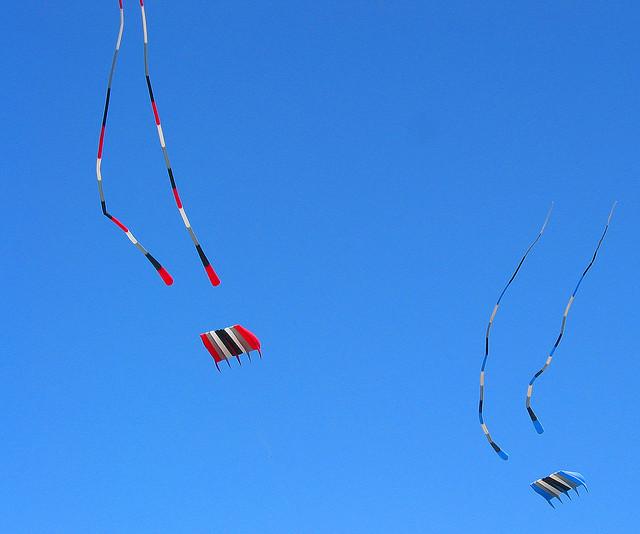What is flying in the air?
Be succinct. Kites. Where kite is blue?
Short answer required. Right. Are the kites small?
Be succinct. No. 